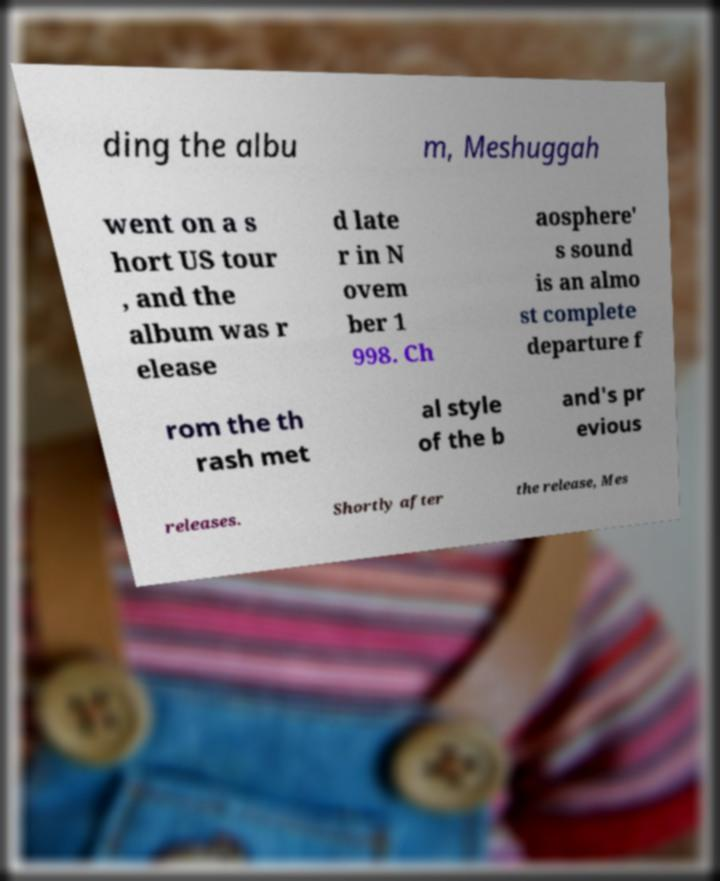Can you accurately transcribe the text from the provided image for me? ding the albu m, Meshuggah went on a s hort US tour , and the album was r elease d late r in N ovem ber 1 998. Ch aosphere' s sound is an almo st complete departure f rom the th rash met al style of the b and's pr evious releases. Shortly after the release, Mes 